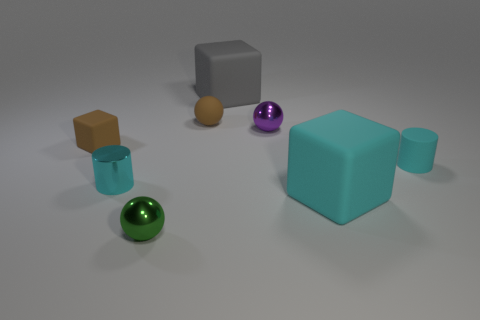There is a metallic sphere behind the brown matte cube; is its color the same as the tiny matte block?
Offer a very short reply. No. What number of objects are shiny things behind the cyan metal thing or tiny purple rubber cubes?
Make the answer very short. 1. There is a small cyan matte cylinder; are there any big things on the right side of it?
Offer a terse response. No. There is another cylinder that is the same color as the tiny rubber cylinder; what is it made of?
Provide a short and direct response. Metal. Does the big cyan object to the right of the gray block have the same material as the small block?
Provide a short and direct response. Yes. There is a small metal ball in front of the large object in front of the tiny rubber sphere; are there any matte things that are in front of it?
Your response must be concise. No. What number of cubes are either small green shiny objects or big cyan objects?
Your answer should be very brief. 1. There is a cyan object to the left of the green thing; what material is it?
Give a very brief answer. Metal. What is the size of the rubber block that is the same color as the shiny cylinder?
Keep it short and to the point. Large. There is a shiny object that is in front of the big cyan rubber cube; does it have the same color as the tiny shiny thing that is on the right side of the gray block?
Provide a succinct answer. No. 